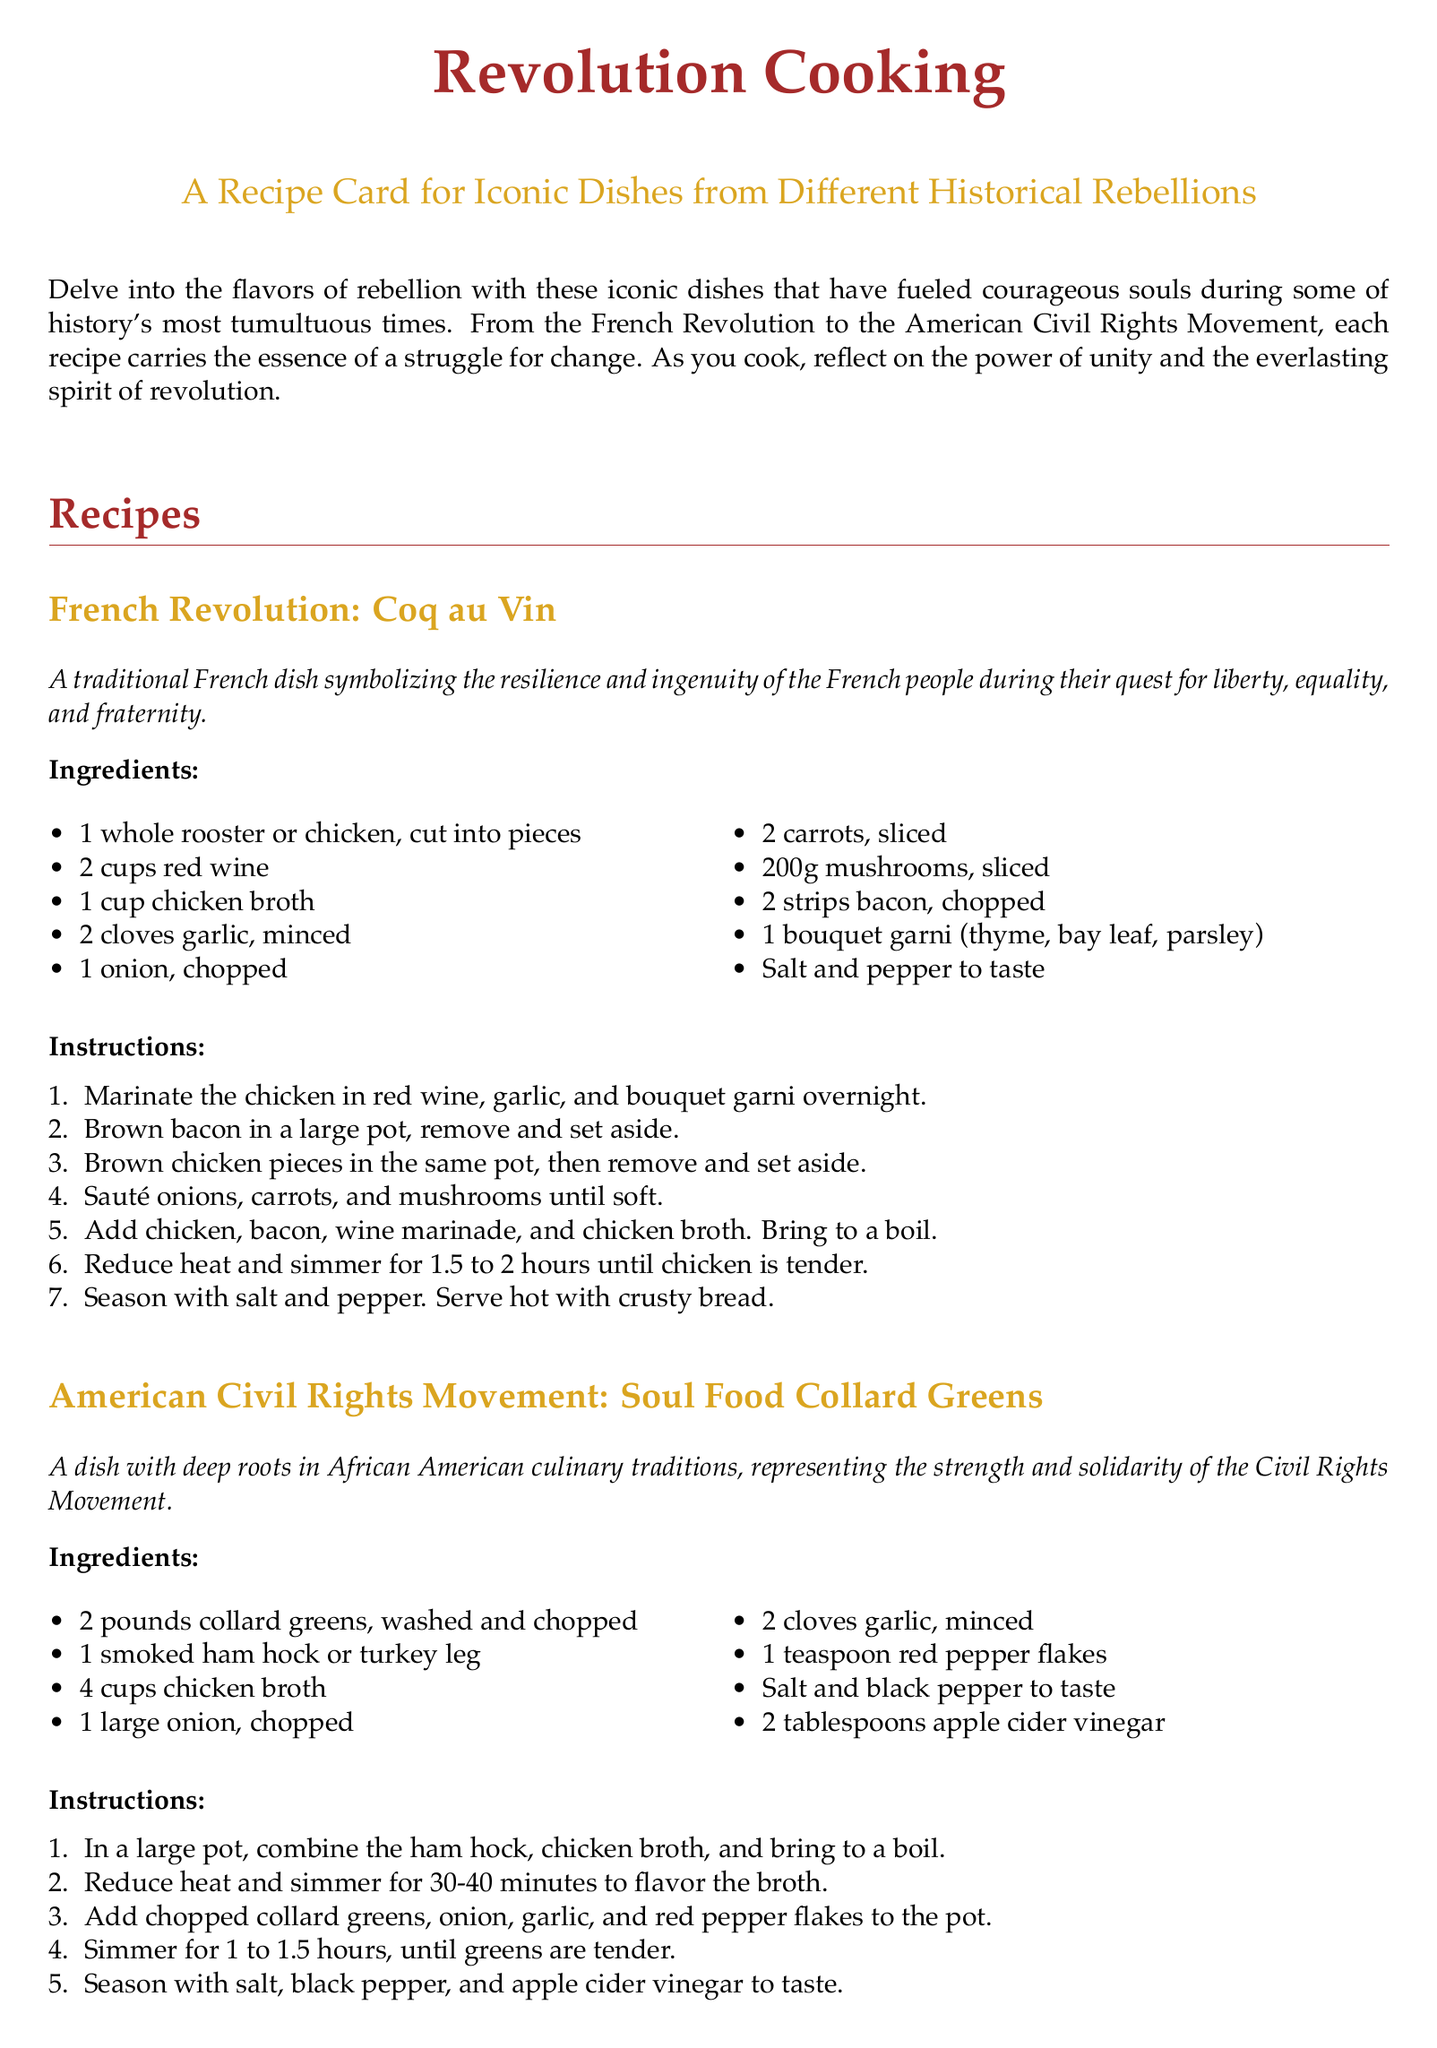What dish represents the French Revolution? The document specifically lists Coq au Vin as the dish representing the French Revolution.
Answer: Coq au Vin What ingredient is used in Soul Food Collard Greens for flavor? The document mentions smoked ham hock as an ingredient used to flavor the broth.
Answer: Smoked ham hock How many pounds of collard greens are needed? According to the recipe, 2 pounds of collard greens are required for the dish.
Answer: 2 pounds What is the cooking time for Coq au Vin? The recipe states that Coq au Vin should be simmered for 1.5 to 2 hours until the chicken is tender.
Answer: 1.5 to 2 hours What type of wine is used in Coq au Vin? The recipe specifies that 2 cups red wine are used in the preparation of the dish.
Answer: Red wine What movement does the Soul Food Collard Greens recipe relate to? The document indicates that this dish represents the American Civil Rights Movement.
Answer: American Civil Rights Movement How many cloves of garlic are used in the French Revolution dish? The ingredient list states that 2 cloves of garlic are required for Coq au Vin.
Answer: 2 cloves What is the purpose of the revolution cooking theme? The introduction explains that the theme is to explore the flavors of rebellion through iconic dishes.
Answer: Explore the flavors of rebellion What is a bouquet garni? The recipe lists bouquet garni as an ingredient in Coq au Vin, which consists of herbs tied together.
Answer: Herbs tied together 